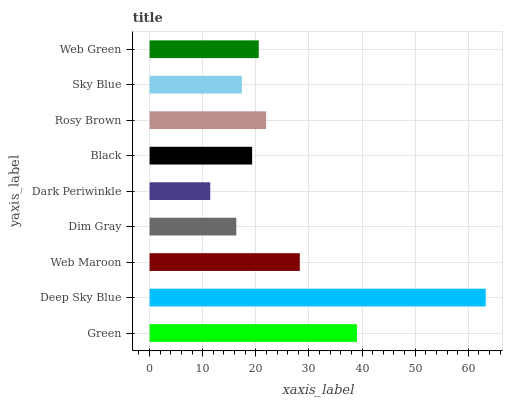Is Dark Periwinkle the minimum?
Answer yes or no. Yes. Is Deep Sky Blue the maximum?
Answer yes or no. Yes. Is Web Maroon the minimum?
Answer yes or no. No. Is Web Maroon the maximum?
Answer yes or no. No. Is Deep Sky Blue greater than Web Maroon?
Answer yes or no. Yes. Is Web Maroon less than Deep Sky Blue?
Answer yes or no. Yes. Is Web Maroon greater than Deep Sky Blue?
Answer yes or no. No. Is Deep Sky Blue less than Web Maroon?
Answer yes or no. No. Is Web Green the high median?
Answer yes or no. Yes. Is Web Green the low median?
Answer yes or no. Yes. Is Black the high median?
Answer yes or no. No. Is Dim Gray the low median?
Answer yes or no. No. 